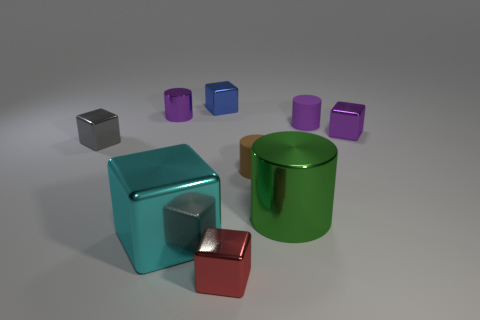What number of objects are either shiny objects to the left of the green metallic thing or brown metal blocks?
Your answer should be compact. 5. There is a metallic cylinder that is the same size as the blue metal object; what is its color?
Make the answer very short. Purple. Are there more small brown rubber cylinders behind the tiny purple matte cylinder than objects?
Your response must be concise. No. The cube that is behind the gray thing and in front of the blue shiny cube is made of what material?
Keep it short and to the point. Metal. There is a rubber cylinder that is behind the small brown cylinder; is it the same color as the metal cylinder on the left side of the blue thing?
Keep it short and to the point. Yes. How many other things are the same size as the cyan cube?
Offer a very short reply. 1. There is a metal thing that is behind the small cylinder that is to the left of the red shiny block; is there a shiny cylinder on the left side of it?
Your answer should be very brief. Yes. Does the big object on the left side of the blue metallic cube have the same material as the big green cylinder?
Your answer should be very brief. Yes. What is the color of the other matte object that is the same shape as the small purple rubber object?
Offer a terse response. Brown. Is there any other thing that is the same shape as the big cyan object?
Your response must be concise. Yes. 